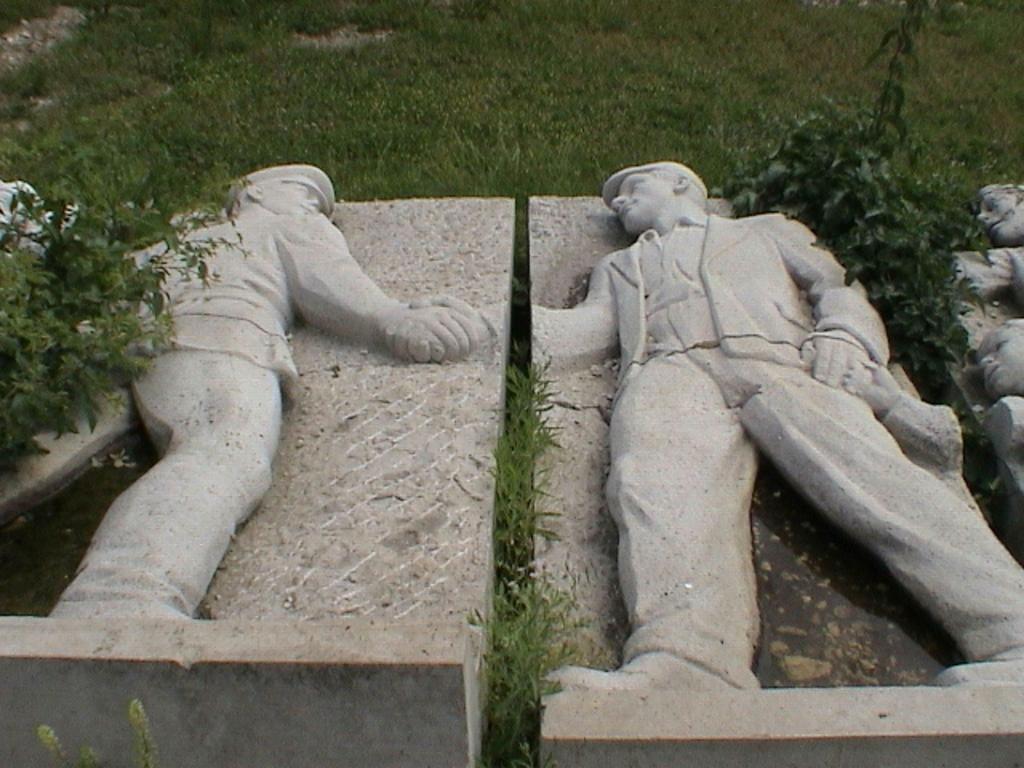Could you give a brief overview of what you see in this image? In this image there is the grass, there are plants, there is plant truncated towards the left of the image, there are sculptors of person, a sculptor is truncated towards the right of the image, a sculptor is truncated towards the left of the image. 